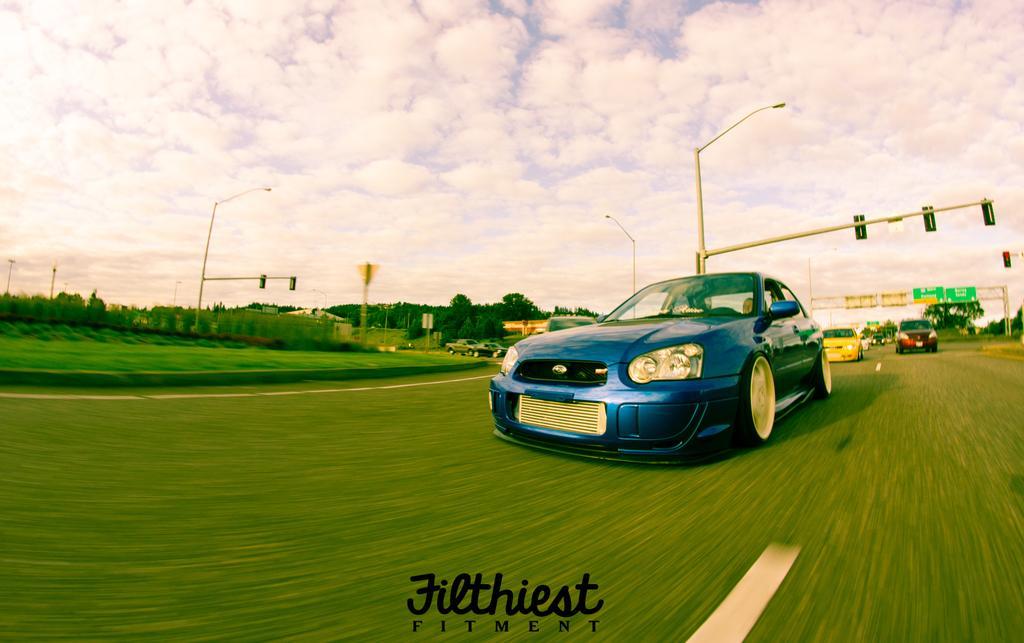Could you give a brief overview of what you see in this image? In the image I can see some cars on the road and around there are some trees, plants and some poles which has some boards and lights. 